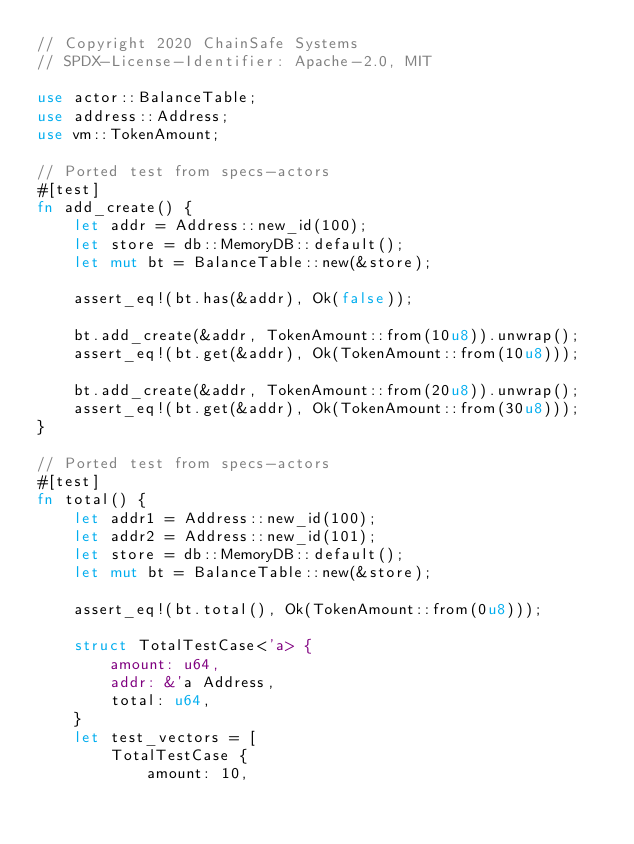<code> <loc_0><loc_0><loc_500><loc_500><_Rust_>// Copyright 2020 ChainSafe Systems
// SPDX-License-Identifier: Apache-2.0, MIT

use actor::BalanceTable;
use address::Address;
use vm::TokenAmount;

// Ported test from specs-actors
#[test]
fn add_create() {
    let addr = Address::new_id(100);
    let store = db::MemoryDB::default();
    let mut bt = BalanceTable::new(&store);

    assert_eq!(bt.has(&addr), Ok(false));

    bt.add_create(&addr, TokenAmount::from(10u8)).unwrap();
    assert_eq!(bt.get(&addr), Ok(TokenAmount::from(10u8)));

    bt.add_create(&addr, TokenAmount::from(20u8)).unwrap();
    assert_eq!(bt.get(&addr), Ok(TokenAmount::from(30u8)));
}

// Ported test from specs-actors
#[test]
fn total() {
    let addr1 = Address::new_id(100);
    let addr2 = Address::new_id(101);
    let store = db::MemoryDB::default();
    let mut bt = BalanceTable::new(&store);

    assert_eq!(bt.total(), Ok(TokenAmount::from(0u8)));

    struct TotalTestCase<'a> {
        amount: u64,
        addr: &'a Address,
        total: u64,
    }
    let test_vectors = [
        TotalTestCase {
            amount: 10,</code> 